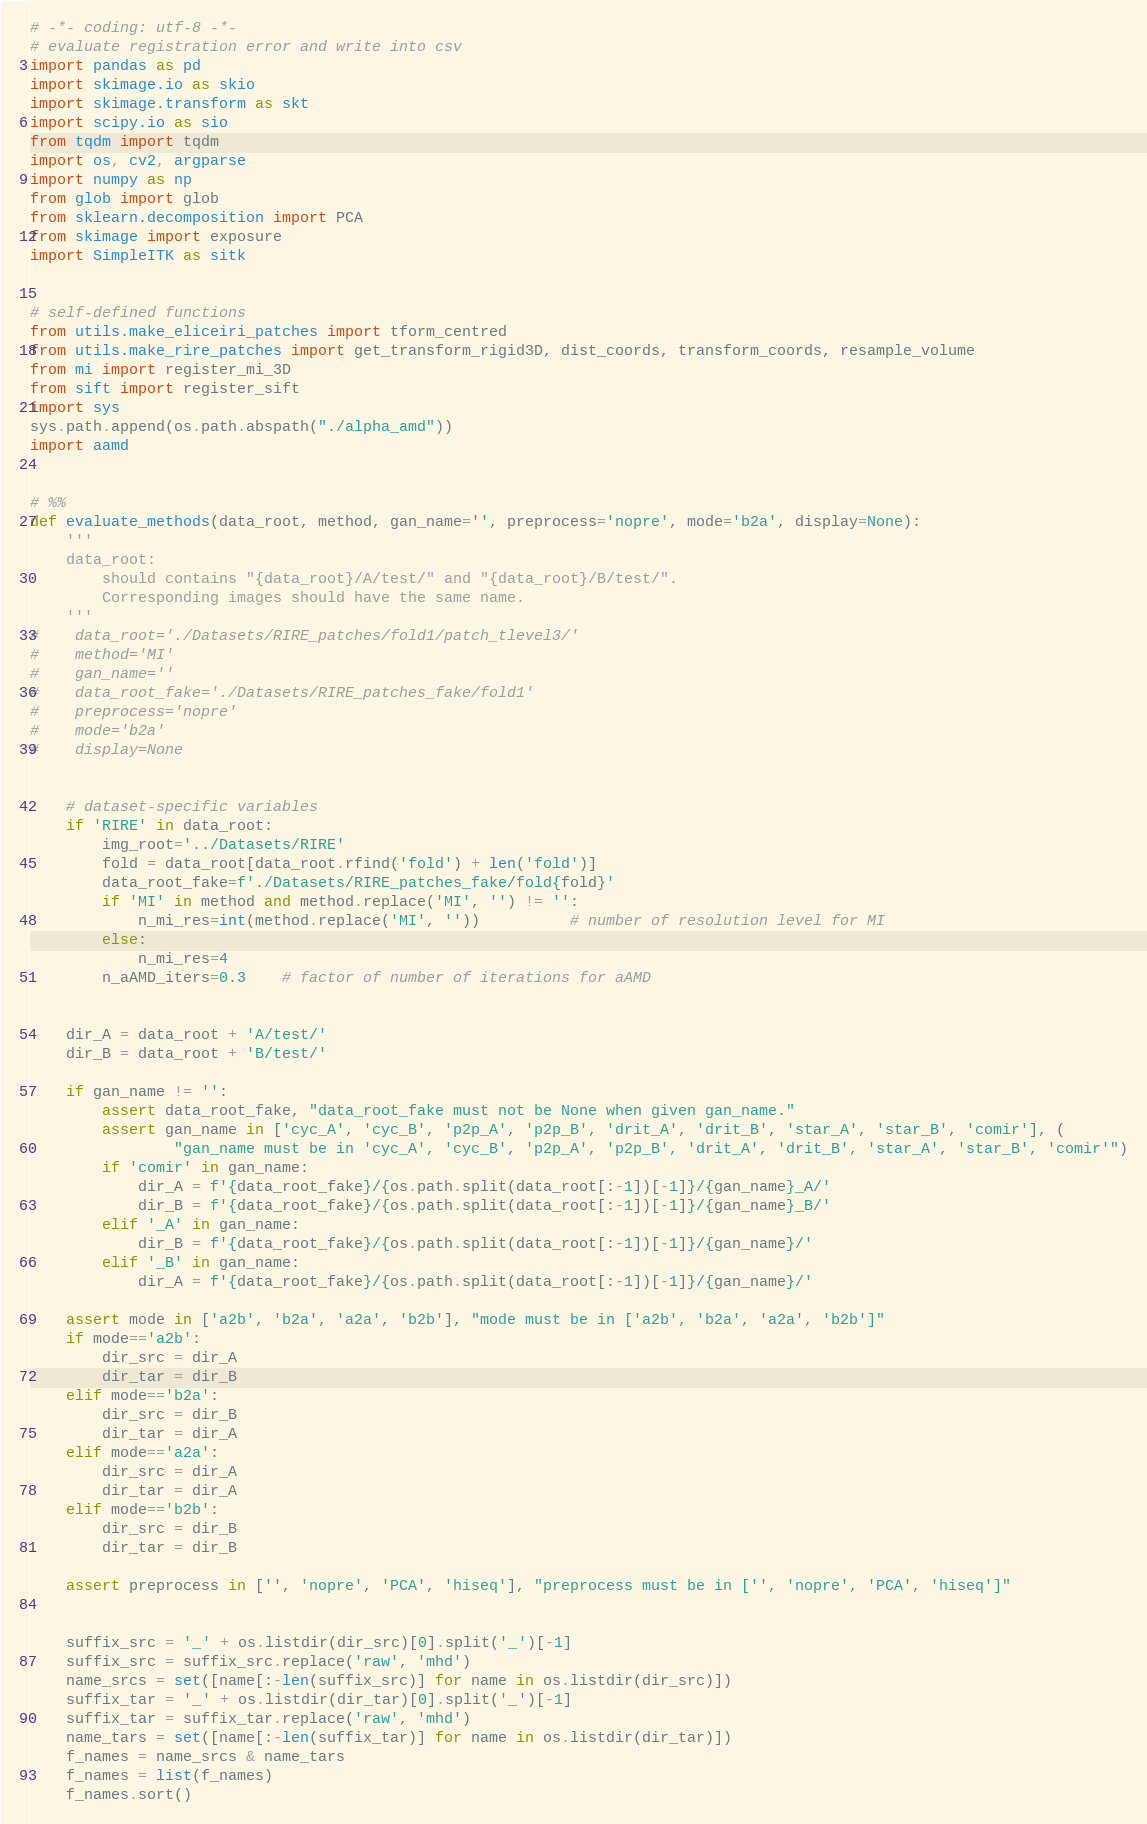<code> <loc_0><loc_0><loc_500><loc_500><_Python_># -*- coding: utf-8 -*-
# evaluate registration error and write into csv
import pandas as pd
import skimage.io as skio
import skimage.transform as skt
import scipy.io as sio
from tqdm import tqdm
import os, cv2, argparse
import numpy as np
from glob import glob
from sklearn.decomposition import PCA
from skimage import exposure
import SimpleITK as sitk


# self-defined functions
from utils.make_eliceiri_patches import tform_centred
from utils.make_rire_patches import get_transform_rigid3D, dist_coords, transform_coords, resample_volume
from mi import register_mi_3D
from sift import register_sift
import sys
sys.path.append(os.path.abspath("./alpha_amd"))
import aamd


# %%
def evaluate_methods(data_root, method, gan_name='', preprocess='nopre', mode='b2a', display=None):
    '''
    data_root: 
        should contains "{data_root}/A/test/" and "{data_root}/B/test/". 
        Corresponding images should have the same name.
    '''
#    data_root='./Datasets/RIRE_patches/fold1/patch_tlevel3/'
#    method='MI'
#    gan_name=''
#    data_root_fake='./Datasets/RIRE_patches_fake/fold1'
#    preprocess='nopre'
#    mode='b2a'
#    display=None

    
    # dataset-specific variables
    if 'RIRE' in data_root:
        img_root='../Datasets/RIRE'
        fold = data_root[data_root.rfind('fold') + len('fold')]
        data_root_fake=f'./Datasets/RIRE_patches_fake/fold{fold}'
        if 'MI' in method and method.replace('MI', '') != '':
            n_mi_res=int(method.replace('MI', ''))          # number of resolution level for MI
        else:
            n_mi_res=4
        n_aAMD_iters=0.3    # factor of number of iterations for aAMD
    
    
    dir_A = data_root + 'A/test/'
    dir_B = data_root + 'B/test/'
    
    if gan_name != '':
        assert data_root_fake, "data_root_fake must not be None when given gan_name."
        assert gan_name in ['cyc_A', 'cyc_B', 'p2p_A', 'p2p_B', 'drit_A', 'drit_B', 'star_A', 'star_B', 'comir'], (
                "gan_name must be in 'cyc_A', 'cyc_B', 'p2p_A', 'p2p_B', 'drit_A', 'drit_B', 'star_A', 'star_B', 'comir'")
        if 'comir' in gan_name:
            dir_A = f'{data_root_fake}/{os.path.split(data_root[:-1])[-1]}/{gan_name}_A/'
            dir_B = f'{data_root_fake}/{os.path.split(data_root[:-1])[-1]}/{gan_name}_B/'
        elif '_A' in gan_name:
            dir_B = f'{data_root_fake}/{os.path.split(data_root[:-1])[-1]}/{gan_name}/'
        elif '_B' in gan_name:
            dir_A = f'{data_root_fake}/{os.path.split(data_root[:-1])[-1]}/{gan_name}/'
    
    assert mode in ['a2b', 'b2a', 'a2a', 'b2b'], "mode must be in ['a2b', 'b2a', 'a2a', 'b2b']"
    if mode=='a2b':
        dir_src = dir_A
        dir_tar = dir_B
    elif mode=='b2a':
        dir_src = dir_B
        dir_tar = dir_A
    elif mode=='a2a':
        dir_src = dir_A
        dir_tar = dir_A
    elif mode=='b2b':
        dir_src = dir_B
        dir_tar = dir_B
        
    assert preprocess in ['', 'nopre', 'PCA', 'hiseq'], "preprocess must be in ['', 'nopre', 'PCA', 'hiseq']"
    

    suffix_src = '_' + os.listdir(dir_src)[0].split('_')[-1]
    suffix_src = suffix_src.replace('raw', 'mhd')
    name_srcs = set([name[:-len(suffix_src)] for name in os.listdir(dir_src)])
    suffix_tar = '_' + os.listdir(dir_tar)[0].split('_')[-1]
    suffix_tar = suffix_tar.replace('raw', 'mhd')
    name_tars = set([name[:-len(suffix_tar)] for name in os.listdir(dir_tar)])
    f_names = name_srcs & name_tars
    f_names = list(f_names)
    f_names.sort()</code> 